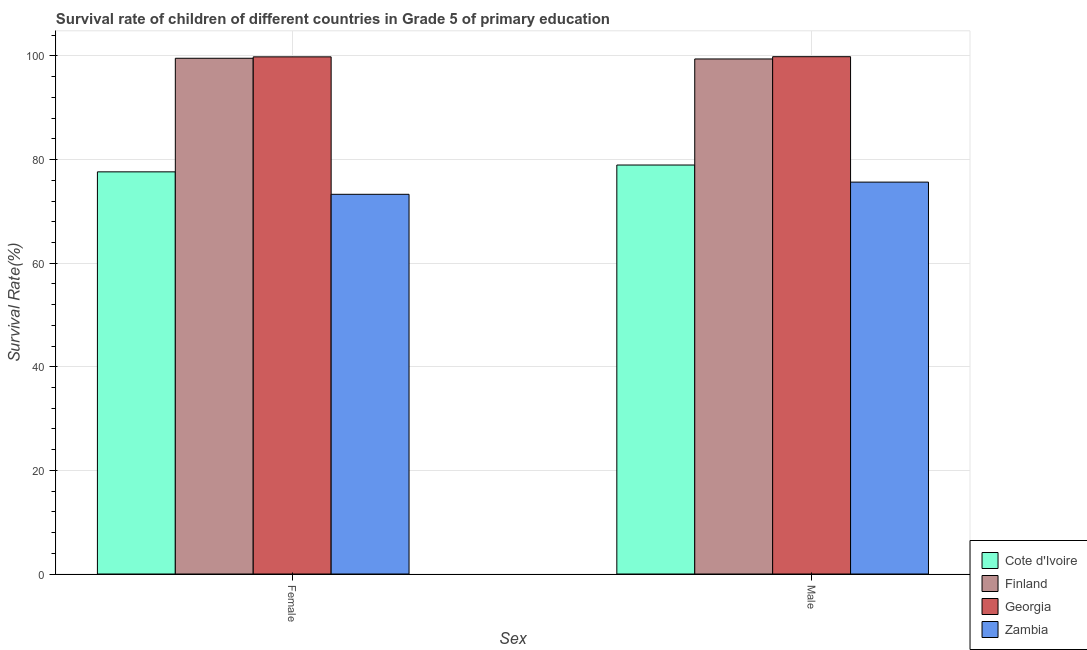How many groups of bars are there?
Ensure brevity in your answer.  2. How many bars are there on the 2nd tick from the left?
Keep it short and to the point. 4. What is the label of the 1st group of bars from the left?
Provide a succinct answer. Female. What is the survival rate of female students in primary education in Cote d'Ivoire?
Provide a short and direct response. 77.63. Across all countries, what is the maximum survival rate of male students in primary education?
Give a very brief answer. 99.86. Across all countries, what is the minimum survival rate of female students in primary education?
Provide a succinct answer. 73.3. In which country was the survival rate of male students in primary education maximum?
Give a very brief answer. Georgia. In which country was the survival rate of male students in primary education minimum?
Make the answer very short. Zambia. What is the total survival rate of male students in primary education in the graph?
Make the answer very short. 353.88. What is the difference between the survival rate of male students in primary education in Cote d'Ivoire and that in Finland?
Keep it short and to the point. -20.48. What is the difference between the survival rate of female students in primary education in Zambia and the survival rate of male students in primary education in Georgia?
Offer a terse response. -26.57. What is the average survival rate of male students in primary education per country?
Your response must be concise. 88.47. What is the difference between the survival rate of female students in primary education and survival rate of male students in primary education in Georgia?
Your response must be concise. -0.03. What is the ratio of the survival rate of male students in primary education in Finland to that in Cote d'Ivoire?
Your answer should be very brief. 1.26. Is the survival rate of female students in primary education in Georgia less than that in Finland?
Offer a very short reply. No. In how many countries, is the survival rate of male students in primary education greater than the average survival rate of male students in primary education taken over all countries?
Provide a succinct answer. 2. What does the 4th bar from the left in Female represents?
Offer a very short reply. Zambia. What does the 3rd bar from the right in Male represents?
Your answer should be very brief. Finland. How many bars are there?
Ensure brevity in your answer.  8. Are all the bars in the graph horizontal?
Provide a succinct answer. No. How many countries are there in the graph?
Provide a short and direct response. 4. What is the difference between two consecutive major ticks on the Y-axis?
Offer a very short reply. 20. Does the graph contain any zero values?
Offer a very short reply. No. Does the graph contain grids?
Your answer should be very brief. Yes. How many legend labels are there?
Provide a succinct answer. 4. What is the title of the graph?
Give a very brief answer. Survival rate of children of different countries in Grade 5 of primary education. Does "Switzerland" appear as one of the legend labels in the graph?
Keep it short and to the point. No. What is the label or title of the X-axis?
Provide a succinct answer. Sex. What is the label or title of the Y-axis?
Make the answer very short. Survival Rate(%). What is the Survival Rate(%) in Cote d'Ivoire in Female?
Your response must be concise. 77.63. What is the Survival Rate(%) in Finland in Female?
Keep it short and to the point. 99.56. What is the Survival Rate(%) in Georgia in Female?
Give a very brief answer. 99.83. What is the Survival Rate(%) in Zambia in Female?
Your answer should be very brief. 73.3. What is the Survival Rate(%) in Cote d'Ivoire in Male?
Keep it short and to the point. 78.95. What is the Survival Rate(%) of Finland in Male?
Make the answer very short. 99.42. What is the Survival Rate(%) in Georgia in Male?
Your answer should be compact. 99.86. What is the Survival Rate(%) in Zambia in Male?
Your answer should be very brief. 75.65. Across all Sex, what is the maximum Survival Rate(%) of Cote d'Ivoire?
Keep it short and to the point. 78.95. Across all Sex, what is the maximum Survival Rate(%) in Finland?
Make the answer very short. 99.56. Across all Sex, what is the maximum Survival Rate(%) of Georgia?
Offer a very short reply. 99.86. Across all Sex, what is the maximum Survival Rate(%) in Zambia?
Your answer should be very brief. 75.65. Across all Sex, what is the minimum Survival Rate(%) of Cote d'Ivoire?
Keep it short and to the point. 77.63. Across all Sex, what is the minimum Survival Rate(%) of Finland?
Your answer should be compact. 99.42. Across all Sex, what is the minimum Survival Rate(%) in Georgia?
Make the answer very short. 99.83. Across all Sex, what is the minimum Survival Rate(%) of Zambia?
Your answer should be compact. 73.3. What is the total Survival Rate(%) in Cote d'Ivoire in the graph?
Provide a succinct answer. 156.58. What is the total Survival Rate(%) in Finland in the graph?
Your answer should be very brief. 198.98. What is the total Survival Rate(%) of Georgia in the graph?
Offer a terse response. 199.69. What is the total Survival Rate(%) in Zambia in the graph?
Provide a short and direct response. 148.95. What is the difference between the Survival Rate(%) in Cote d'Ivoire in Female and that in Male?
Ensure brevity in your answer.  -1.32. What is the difference between the Survival Rate(%) of Finland in Female and that in Male?
Give a very brief answer. 0.13. What is the difference between the Survival Rate(%) in Georgia in Female and that in Male?
Make the answer very short. -0.03. What is the difference between the Survival Rate(%) in Zambia in Female and that in Male?
Your answer should be very brief. -2.35. What is the difference between the Survival Rate(%) of Cote d'Ivoire in Female and the Survival Rate(%) of Finland in Male?
Ensure brevity in your answer.  -21.79. What is the difference between the Survival Rate(%) in Cote d'Ivoire in Female and the Survival Rate(%) in Georgia in Male?
Make the answer very short. -22.23. What is the difference between the Survival Rate(%) in Cote d'Ivoire in Female and the Survival Rate(%) in Zambia in Male?
Provide a short and direct response. 1.98. What is the difference between the Survival Rate(%) of Finland in Female and the Survival Rate(%) of Georgia in Male?
Make the answer very short. -0.3. What is the difference between the Survival Rate(%) in Finland in Female and the Survival Rate(%) in Zambia in Male?
Your answer should be compact. 23.91. What is the difference between the Survival Rate(%) in Georgia in Female and the Survival Rate(%) in Zambia in Male?
Provide a succinct answer. 24.18. What is the average Survival Rate(%) in Cote d'Ivoire per Sex?
Provide a short and direct response. 78.29. What is the average Survival Rate(%) of Finland per Sex?
Ensure brevity in your answer.  99.49. What is the average Survival Rate(%) in Georgia per Sex?
Offer a terse response. 99.85. What is the average Survival Rate(%) of Zambia per Sex?
Give a very brief answer. 74.47. What is the difference between the Survival Rate(%) of Cote d'Ivoire and Survival Rate(%) of Finland in Female?
Make the answer very short. -21.93. What is the difference between the Survival Rate(%) in Cote d'Ivoire and Survival Rate(%) in Georgia in Female?
Your response must be concise. -22.2. What is the difference between the Survival Rate(%) of Cote d'Ivoire and Survival Rate(%) of Zambia in Female?
Your answer should be very brief. 4.34. What is the difference between the Survival Rate(%) of Finland and Survival Rate(%) of Georgia in Female?
Offer a very short reply. -0.27. What is the difference between the Survival Rate(%) in Finland and Survival Rate(%) in Zambia in Female?
Provide a succinct answer. 26.26. What is the difference between the Survival Rate(%) of Georgia and Survival Rate(%) of Zambia in Female?
Offer a very short reply. 26.54. What is the difference between the Survival Rate(%) in Cote d'Ivoire and Survival Rate(%) in Finland in Male?
Your answer should be compact. -20.48. What is the difference between the Survival Rate(%) of Cote d'Ivoire and Survival Rate(%) of Georgia in Male?
Keep it short and to the point. -20.91. What is the difference between the Survival Rate(%) of Cote d'Ivoire and Survival Rate(%) of Zambia in Male?
Provide a succinct answer. 3.3. What is the difference between the Survival Rate(%) in Finland and Survival Rate(%) in Georgia in Male?
Provide a short and direct response. -0.44. What is the difference between the Survival Rate(%) of Finland and Survival Rate(%) of Zambia in Male?
Offer a terse response. 23.77. What is the difference between the Survival Rate(%) in Georgia and Survival Rate(%) in Zambia in Male?
Your response must be concise. 24.21. What is the ratio of the Survival Rate(%) of Cote d'Ivoire in Female to that in Male?
Your answer should be compact. 0.98. What is the ratio of the Survival Rate(%) in Georgia in Female to that in Male?
Your answer should be compact. 1. What is the ratio of the Survival Rate(%) of Zambia in Female to that in Male?
Give a very brief answer. 0.97. What is the difference between the highest and the second highest Survival Rate(%) of Cote d'Ivoire?
Keep it short and to the point. 1.32. What is the difference between the highest and the second highest Survival Rate(%) of Finland?
Provide a succinct answer. 0.13. What is the difference between the highest and the second highest Survival Rate(%) of Georgia?
Offer a very short reply. 0.03. What is the difference between the highest and the second highest Survival Rate(%) in Zambia?
Provide a succinct answer. 2.35. What is the difference between the highest and the lowest Survival Rate(%) in Cote d'Ivoire?
Your response must be concise. 1.32. What is the difference between the highest and the lowest Survival Rate(%) of Finland?
Provide a short and direct response. 0.13. What is the difference between the highest and the lowest Survival Rate(%) in Georgia?
Make the answer very short. 0.03. What is the difference between the highest and the lowest Survival Rate(%) in Zambia?
Your answer should be very brief. 2.35. 